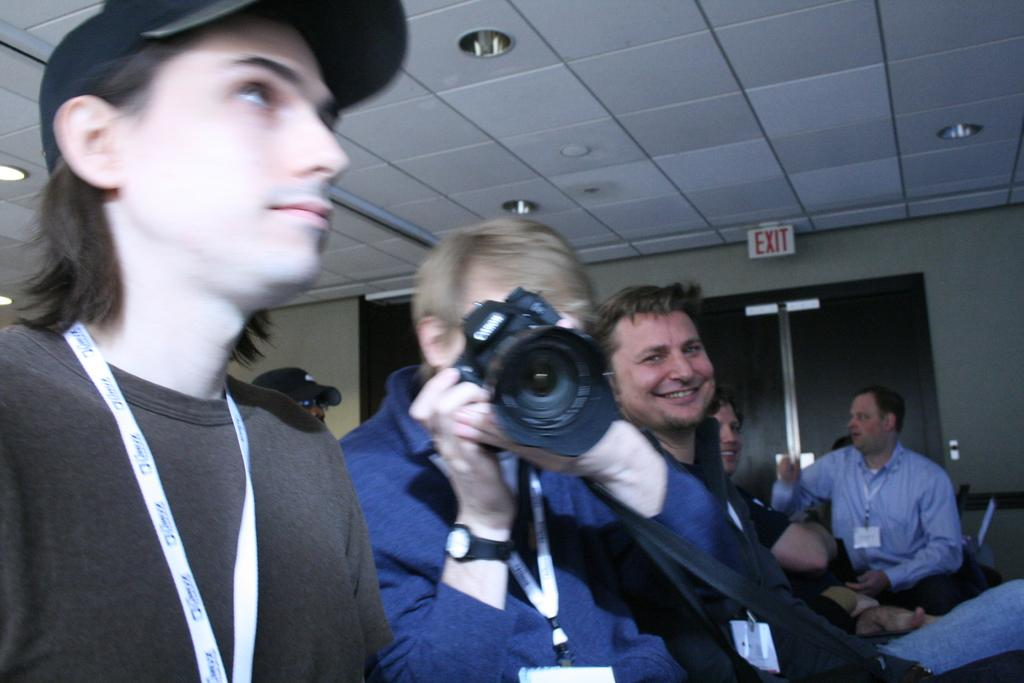How many people are in the image? There are four men in the image. What is one of the men doing in the image? One of the men is holding a camera. What expressions do some of the men have in the image? Two of the men are smiling. What can be seen in the background of the image? There is a wall, a ceiling, and an exit board visible in the background. What is the annual income of the man holding the camera in the image? There is no information about the income of the man holding the camera in the image. How many rail tracks are visible in the image? There are no rail tracks present in the image. 